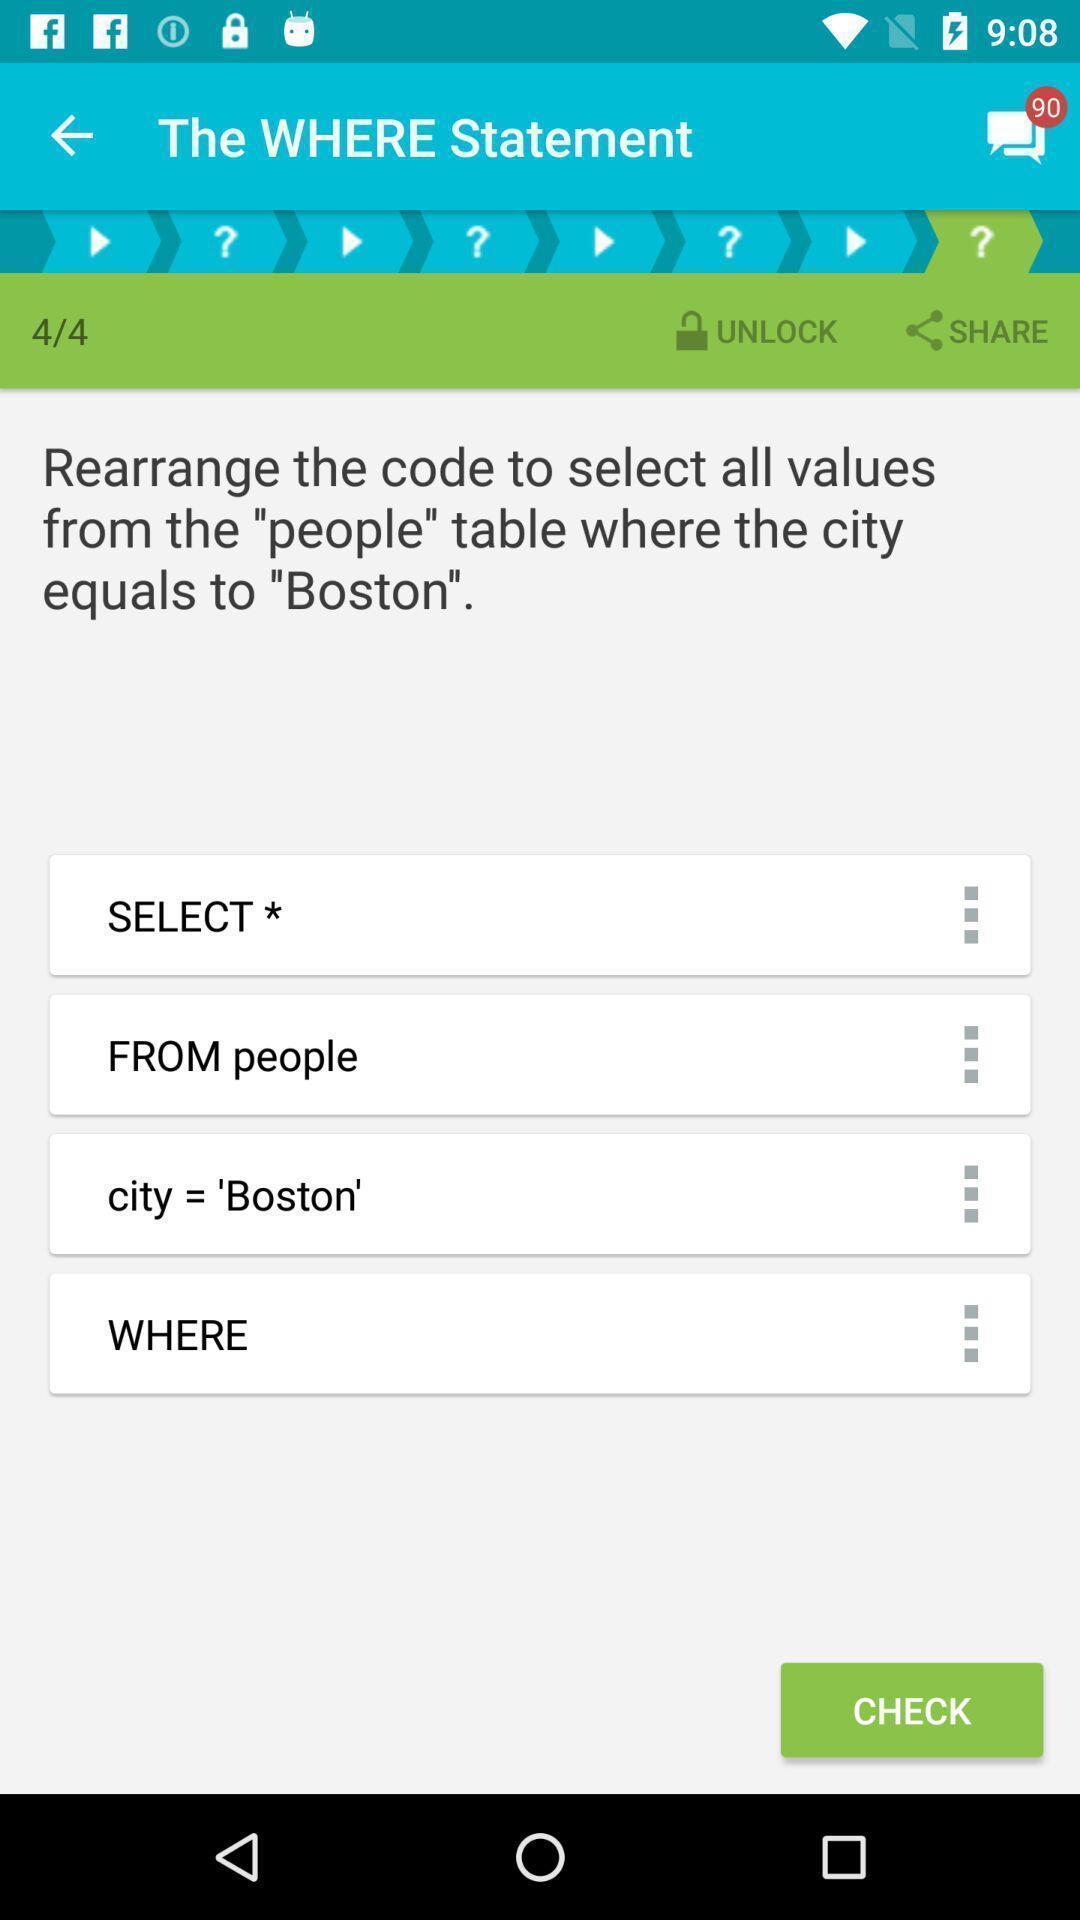Provide a description of this screenshot. Screen shows an all-in-one app. 